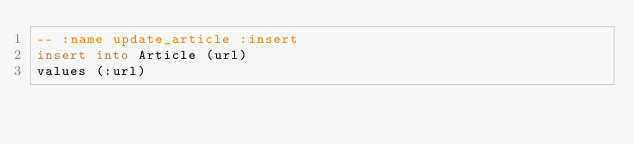<code> <loc_0><loc_0><loc_500><loc_500><_SQL_>-- :name update_article :insert
insert into Article (url)
values (:url)
</code> 